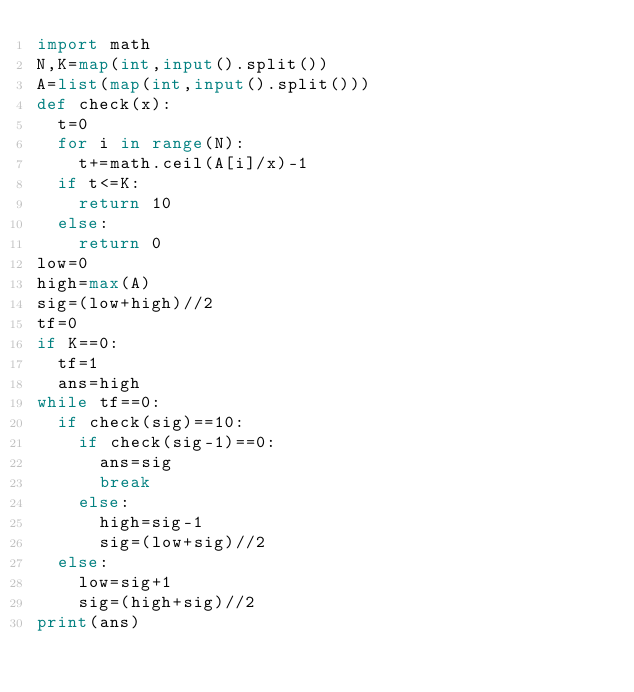Convert code to text. <code><loc_0><loc_0><loc_500><loc_500><_Python_>import math
N,K=map(int,input().split())
A=list(map(int,input().split()))
def check(x):
  t=0
  for i in range(N):
    t+=math.ceil(A[i]/x)-1
  if t<=K:
    return 10
  else:
    return 0
low=0
high=max(A)
sig=(low+high)//2
tf=0
if K==0:
  tf=1
  ans=high
while tf==0:
  if check(sig)==10:
    if check(sig-1)==0:
      ans=sig
      break
    else:
      high=sig-1
      sig=(low+sig)//2
  else:
    low=sig+1
    sig=(high+sig)//2
print(ans)</code> 